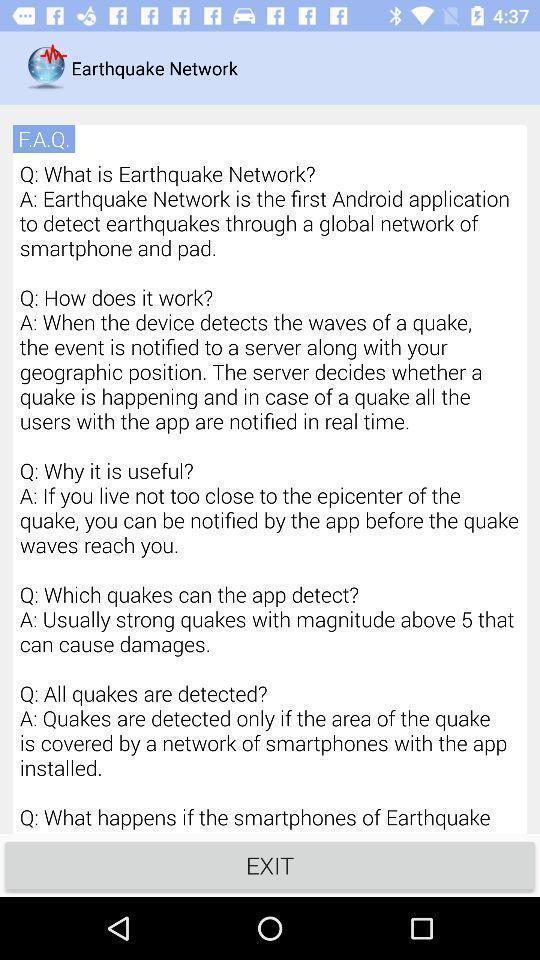Summarize the main components in this picture. Page showing f.a.q for earthquake network. 